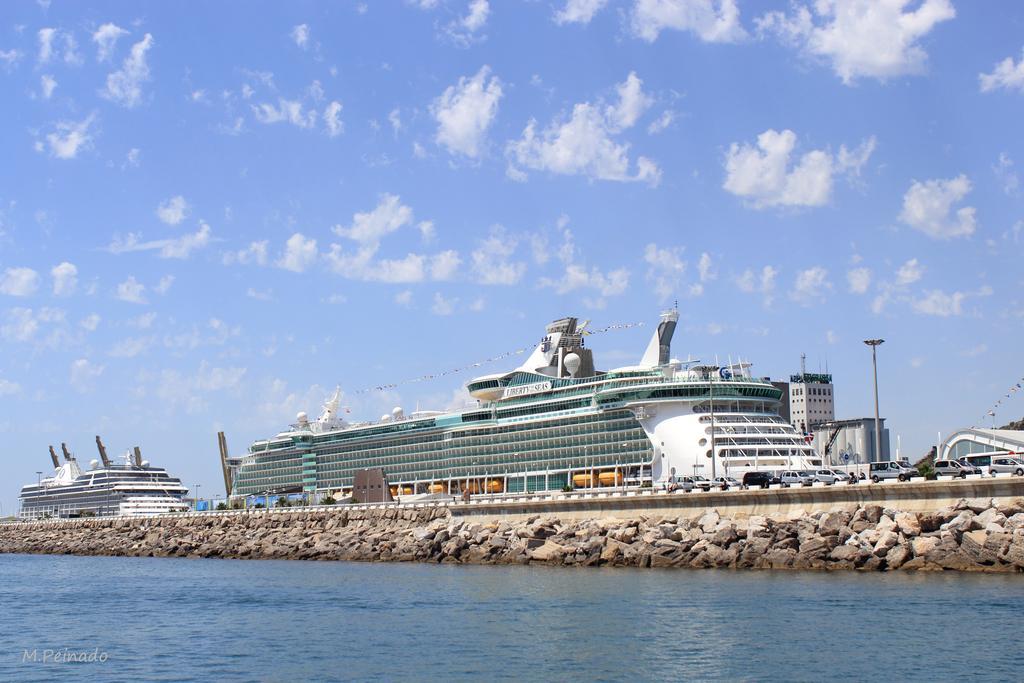Describe this image in one or two sentences. In this picture there is water at the bottom side of the image and there are cars on the bridge in the image and there are ships in the center of the image and there is a pole on the right side of the image. 